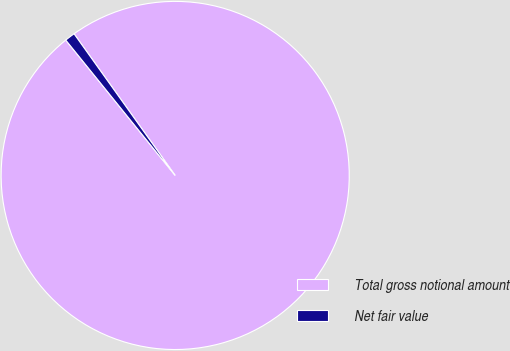<chart> <loc_0><loc_0><loc_500><loc_500><pie_chart><fcel>Total gross notional amount<fcel>Net fair value<nl><fcel>99.05%<fcel>0.95%<nl></chart> 